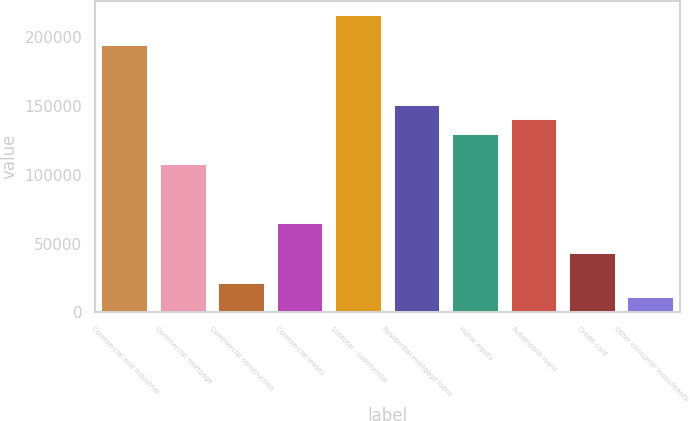Convert chart to OTSL. <chart><loc_0><loc_0><loc_500><loc_500><bar_chart><fcel>Commercial and industrial<fcel>Commercial mortgage<fcel>Commercial construction<fcel>Commercial leases<fcel>Subtotal - commercial<fcel>Residential mortgage loans<fcel>Home equity<fcel>Automobile loans<fcel>Credit card<fcel>Other consumer loans/leases<nl><fcel>194278<fcel>107954<fcel>21630<fcel>64792<fcel>215859<fcel>151116<fcel>129535<fcel>140326<fcel>43211<fcel>10839.5<nl></chart> 